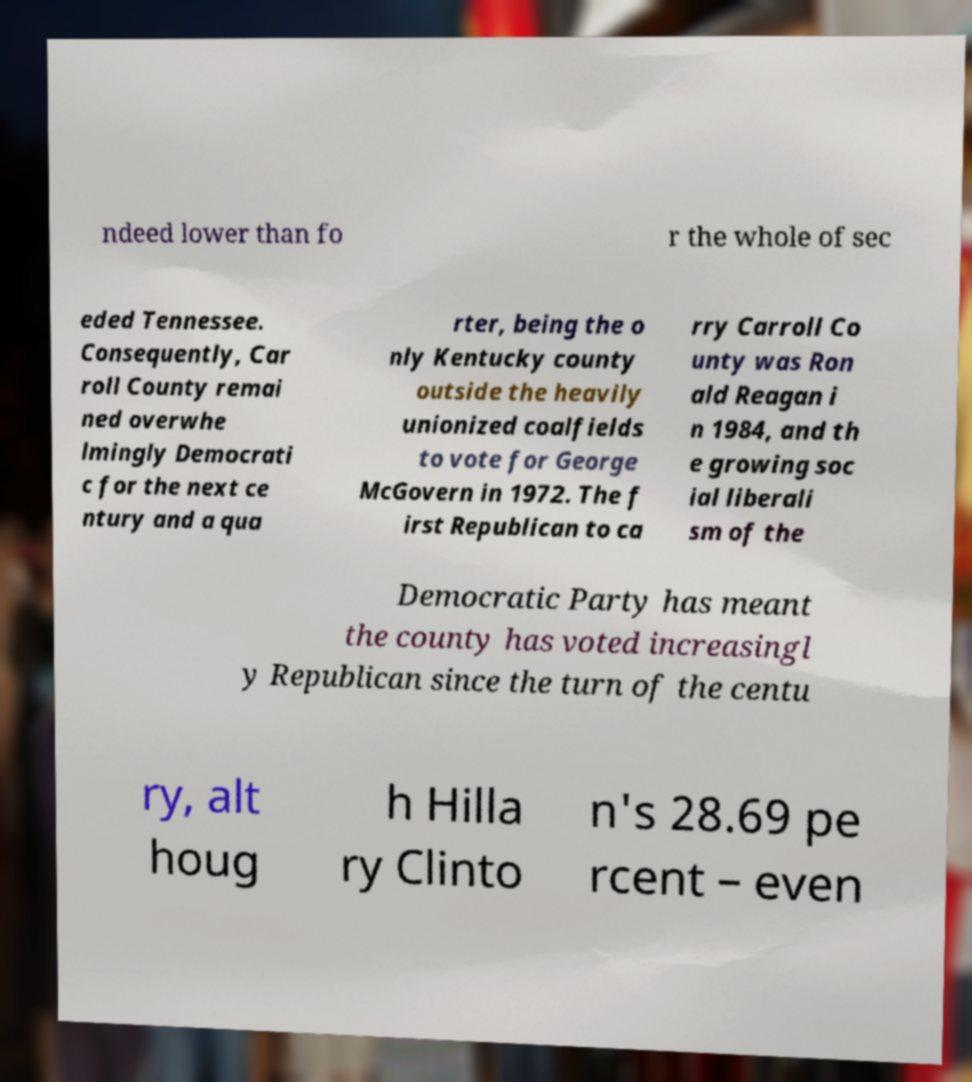Please identify and transcribe the text found in this image. ndeed lower than fo r the whole of sec eded Tennessee. Consequently, Car roll County remai ned overwhe lmingly Democrati c for the next ce ntury and a qua rter, being the o nly Kentucky county outside the heavily unionized coalfields to vote for George McGovern in 1972. The f irst Republican to ca rry Carroll Co unty was Ron ald Reagan i n 1984, and th e growing soc ial liberali sm of the Democratic Party has meant the county has voted increasingl y Republican since the turn of the centu ry, alt houg h Hilla ry Clinto n's 28.69 pe rcent – even 